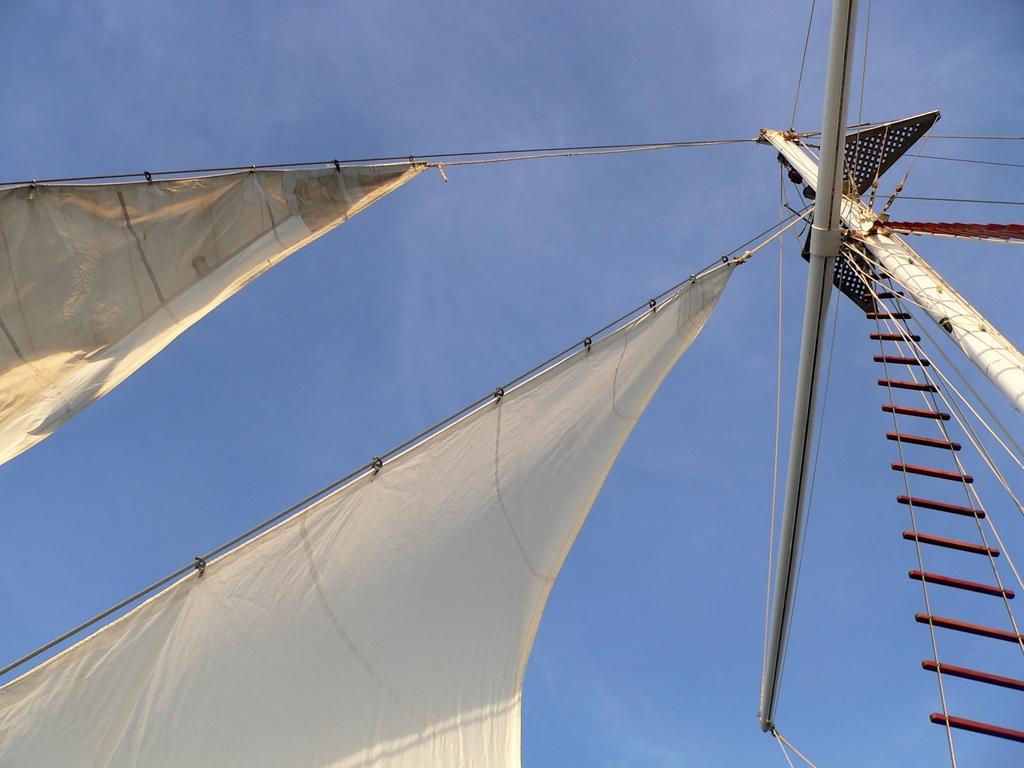Could you give a brief overview of what you see in this image? Here we can see sails, ladder and rods. Background there is a sky. Sky is in blue color.  